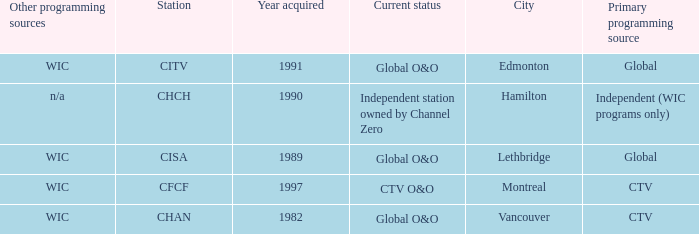How many channels were gained in 1997 1.0. 